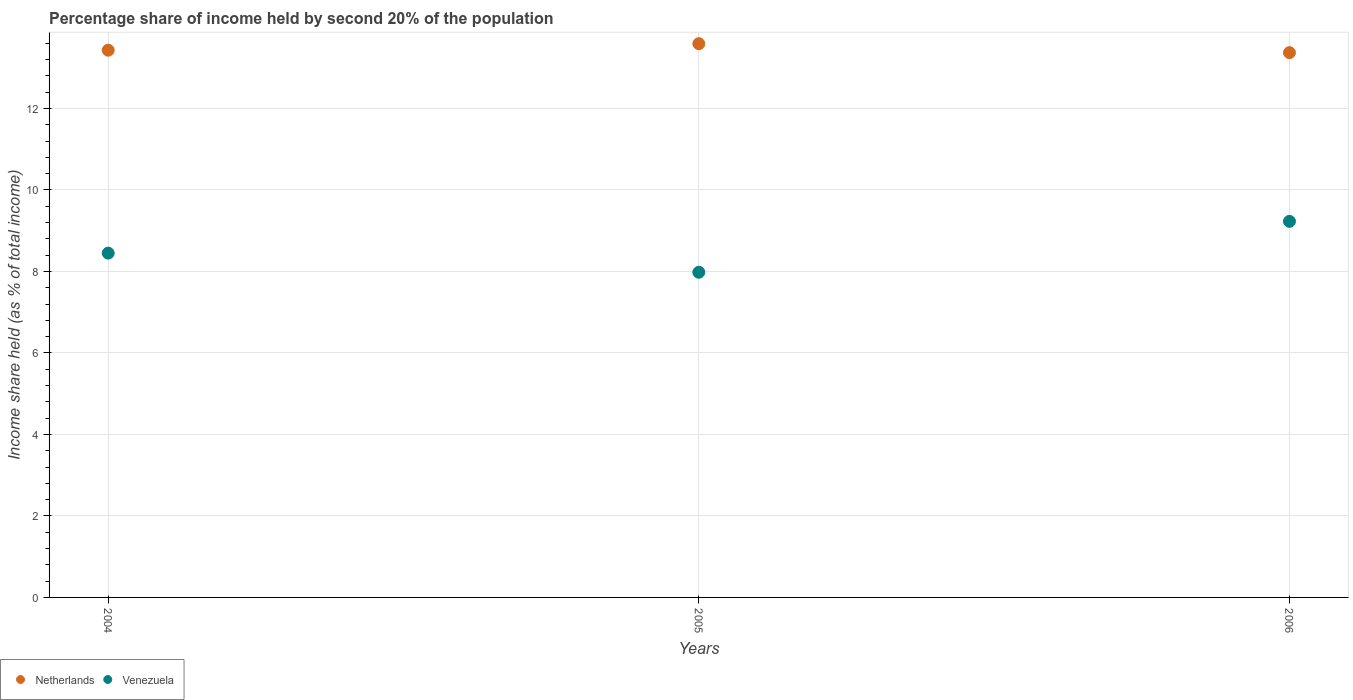Is the number of dotlines equal to the number of legend labels?
Provide a short and direct response. Yes. What is the share of income held by second 20% of the population in Venezuela in 2005?
Give a very brief answer. 7.98. Across all years, what is the maximum share of income held by second 20% of the population in Netherlands?
Provide a succinct answer. 13.59. Across all years, what is the minimum share of income held by second 20% of the population in Netherlands?
Provide a short and direct response. 13.37. In which year was the share of income held by second 20% of the population in Netherlands maximum?
Offer a very short reply. 2005. What is the total share of income held by second 20% of the population in Netherlands in the graph?
Offer a very short reply. 40.39. What is the difference between the share of income held by second 20% of the population in Venezuela in 2004 and that in 2006?
Offer a very short reply. -0.78. What is the difference between the share of income held by second 20% of the population in Netherlands in 2006 and the share of income held by second 20% of the population in Venezuela in 2004?
Offer a terse response. 4.92. What is the average share of income held by second 20% of the population in Venezuela per year?
Your response must be concise. 8.55. In the year 2006, what is the difference between the share of income held by second 20% of the population in Netherlands and share of income held by second 20% of the population in Venezuela?
Give a very brief answer. 4.14. What is the ratio of the share of income held by second 20% of the population in Venezuela in 2004 to that in 2005?
Provide a short and direct response. 1.06. What is the difference between the highest and the second highest share of income held by second 20% of the population in Venezuela?
Offer a terse response. 0.78. What is the difference between the highest and the lowest share of income held by second 20% of the population in Venezuela?
Make the answer very short. 1.25. In how many years, is the share of income held by second 20% of the population in Netherlands greater than the average share of income held by second 20% of the population in Netherlands taken over all years?
Your response must be concise. 1. How many dotlines are there?
Your answer should be very brief. 2. How many years are there in the graph?
Offer a very short reply. 3. What is the difference between two consecutive major ticks on the Y-axis?
Ensure brevity in your answer.  2. Does the graph contain any zero values?
Provide a short and direct response. No. How many legend labels are there?
Your answer should be very brief. 2. How are the legend labels stacked?
Give a very brief answer. Horizontal. What is the title of the graph?
Keep it short and to the point. Percentage share of income held by second 20% of the population. What is the label or title of the X-axis?
Keep it short and to the point. Years. What is the label or title of the Y-axis?
Provide a succinct answer. Income share held (as % of total income). What is the Income share held (as % of total income) in Netherlands in 2004?
Ensure brevity in your answer.  13.43. What is the Income share held (as % of total income) in Venezuela in 2004?
Give a very brief answer. 8.45. What is the Income share held (as % of total income) in Netherlands in 2005?
Offer a terse response. 13.59. What is the Income share held (as % of total income) of Venezuela in 2005?
Offer a terse response. 7.98. What is the Income share held (as % of total income) of Netherlands in 2006?
Give a very brief answer. 13.37. What is the Income share held (as % of total income) of Venezuela in 2006?
Provide a short and direct response. 9.23. Across all years, what is the maximum Income share held (as % of total income) in Netherlands?
Keep it short and to the point. 13.59. Across all years, what is the maximum Income share held (as % of total income) of Venezuela?
Offer a very short reply. 9.23. Across all years, what is the minimum Income share held (as % of total income) in Netherlands?
Keep it short and to the point. 13.37. Across all years, what is the minimum Income share held (as % of total income) in Venezuela?
Provide a short and direct response. 7.98. What is the total Income share held (as % of total income) of Netherlands in the graph?
Give a very brief answer. 40.39. What is the total Income share held (as % of total income) of Venezuela in the graph?
Provide a succinct answer. 25.66. What is the difference between the Income share held (as % of total income) of Netherlands in 2004 and that in 2005?
Offer a very short reply. -0.16. What is the difference between the Income share held (as % of total income) in Venezuela in 2004 and that in 2005?
Offer a terse response. 0.47. What is the difference between the Income share held (as % of total income) of Netherlands in 2004 and that in 2006?
Keep it short and to the point. 0.06. What is the difference between the Income share held (as % of total income) in Venezuela in 2004 and that in 2006?
Your answer should be very brief. -0.78. What is the difference between the Income share held (as % of total income) in Netherlands in 2005 and that in 2006?
Offer a terse response. 0.22. What is the difference between the Income share held (as % of total income) of Venezuela in 2005 and that in 2006?
Offer a terse response. -1.25. What is the difference between the Income share held (as % of total income) in Netherlands in 2004 and the Income share held (as % of total income) in Venezuela in 2005?
Offer a terse response. 5.45. What is the difference between the Income share held (as % of total income) in Netherlands in 2004 and the Income share held (as % of total income) in Venezuela in 2006?
Your answer should be compact. 4.2. What is the difference between the Income share held (as % of total income) in Netherlands in 2005 and the Income share held (as % of total income) in Venezuela in 2006?
Keep it short and to the point. 4.36. What is the average Income share held (as % of total income) in Netherlands per year?
Offer a very short reply. 13.46. What is the average Income share held (as % of total income) of Venezuela per year?
Your answer should be compact. 8.55. In the year 2004, what is the difference between the Income share held (as % of total income) of Netherlands and Income share held (as % of total income) of Venezuela?
Your answer should be very brief. 4.98. In the year 2005, what is the difference between the Income share held (as % of total income) in Netherlands and Income share held (as % of total income) in Venezuela?
Offer a terse response. 5.61. In the year 2006, what is the difference between the Income share held (as % of total income) of Netherlands and Income share held (as % of total income) of Venezuela?
Your answer should be compact. 4.14. What is the ratio of the Income share held (as % of total income) of Venezuela in 2004 to that in 2005?
Make the answer very short. 1.06. What is the ratio of the Income share held (as % of total income) in Netherlands in 2004 to that in 2006?
Make the answer very short. 1. What is the ratio of the Income share held (as % of total income) in Venezuela in 2004 to that in 2006?
Provide a short and direct response. 0.92. What is the ratio of the Income share held (as % of total income) in Netherlands in 2005 to that in 2006?
Your response must be concise. 1.02. What is the ratio of the Income share held (as % of total income) in Venezuela in 2005 to that in 2006?
Offer a very short reply. 0.86. What is the difference between the highest and the second highest Income share held (as % of total income) in Netherlands?
Provide a succinct answer. 0.16. What is the difference between the highest and the second highest Income share held (as % of total income) in Venezuela?
Make the answer very short. 0.78. What is the difference between the highest and the lowest Income share held (as % of total income) in Netherlands?
Offer a very short reply. 0.22. What is the difference between the highest and the lowest Income share held (as % of total income) in Venezuela?
Your answer should be very brief. 1.25. 